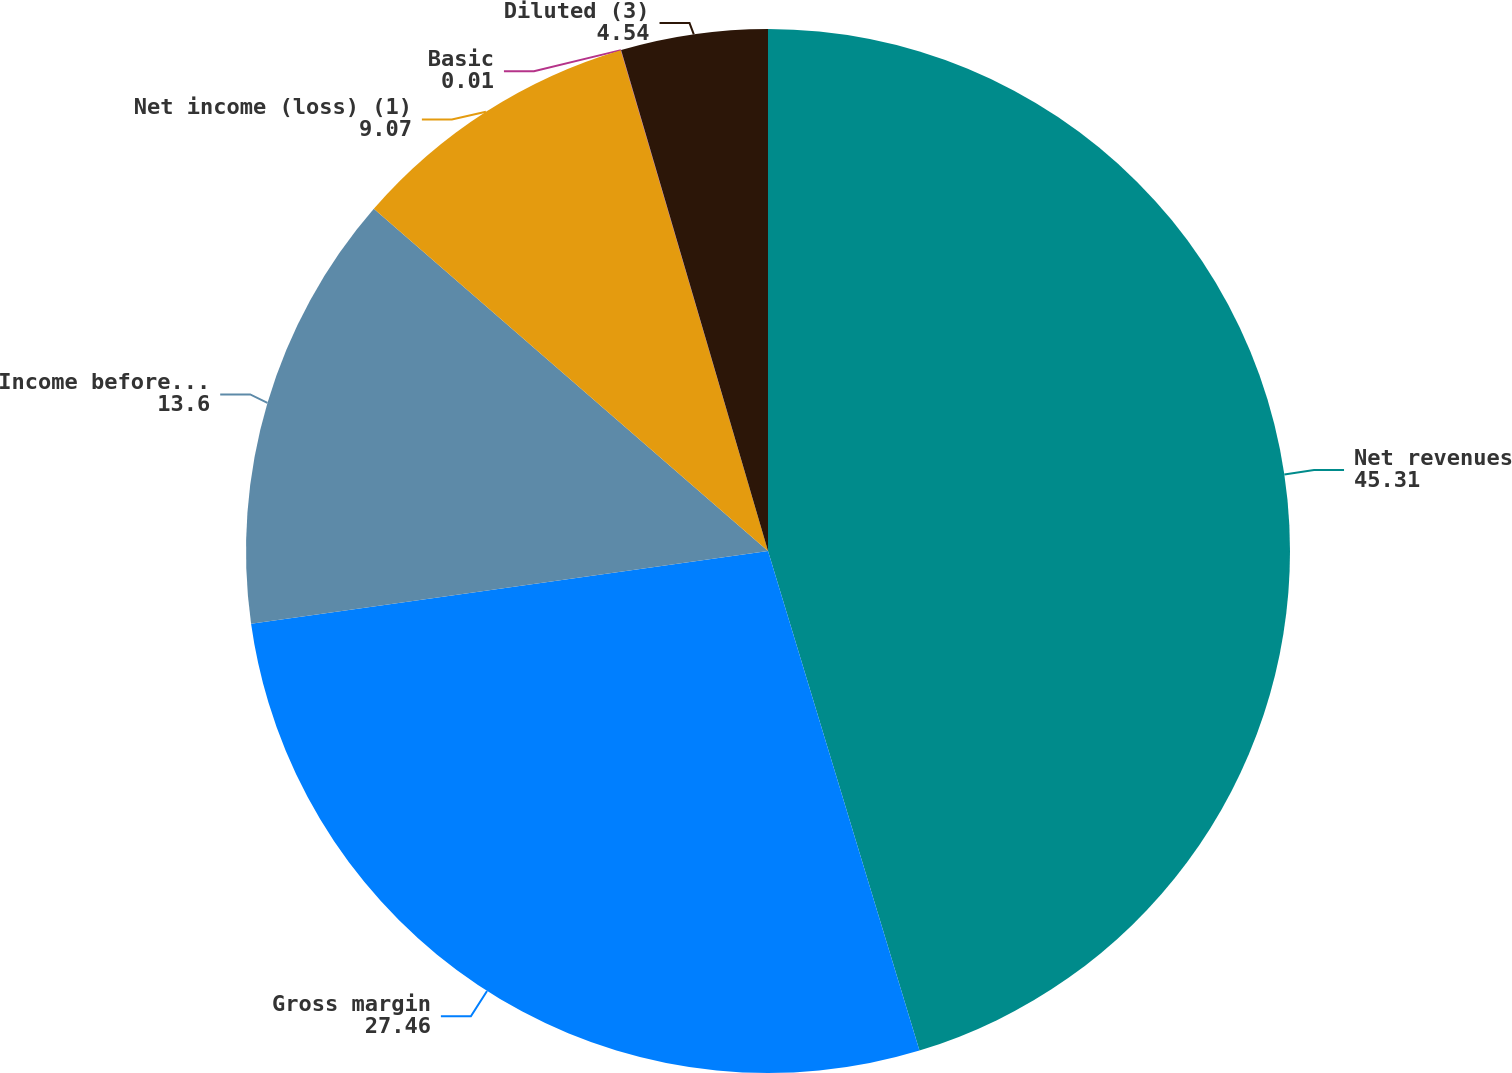<chart> <loc_0><loc_0><loc_500><loc_500><pie_chart><fcel>Net revenues<fcel>Gross margin<fcel>Income before income taxes<fcel>Net income (loss) (1)<fcel>Basic<fcel>Diluted (3)<nl><fcel>45.31%<fcel>27.46%<fcel>13.6%<fcel>9.07%<fcel>0.01%<fcel>4.54%<nl></chart> 